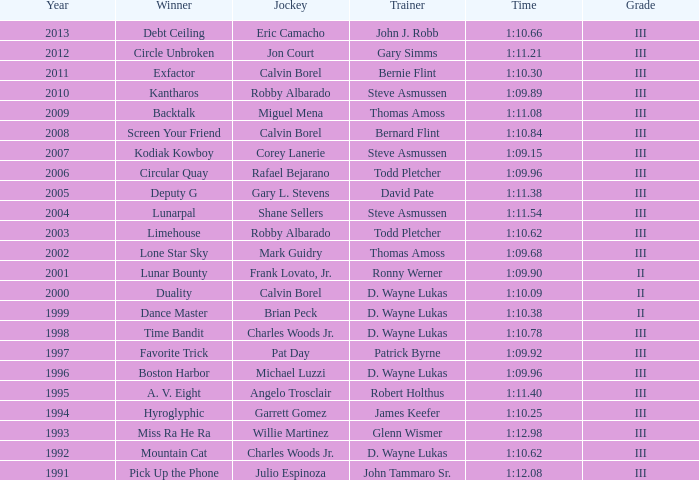In a year before 2009, which instructor clocked a time of 1:10.09? D. Wayne Lukas. 